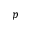<formula> <loc_0><loc_0><loc_500><loc_500>p</formula> 